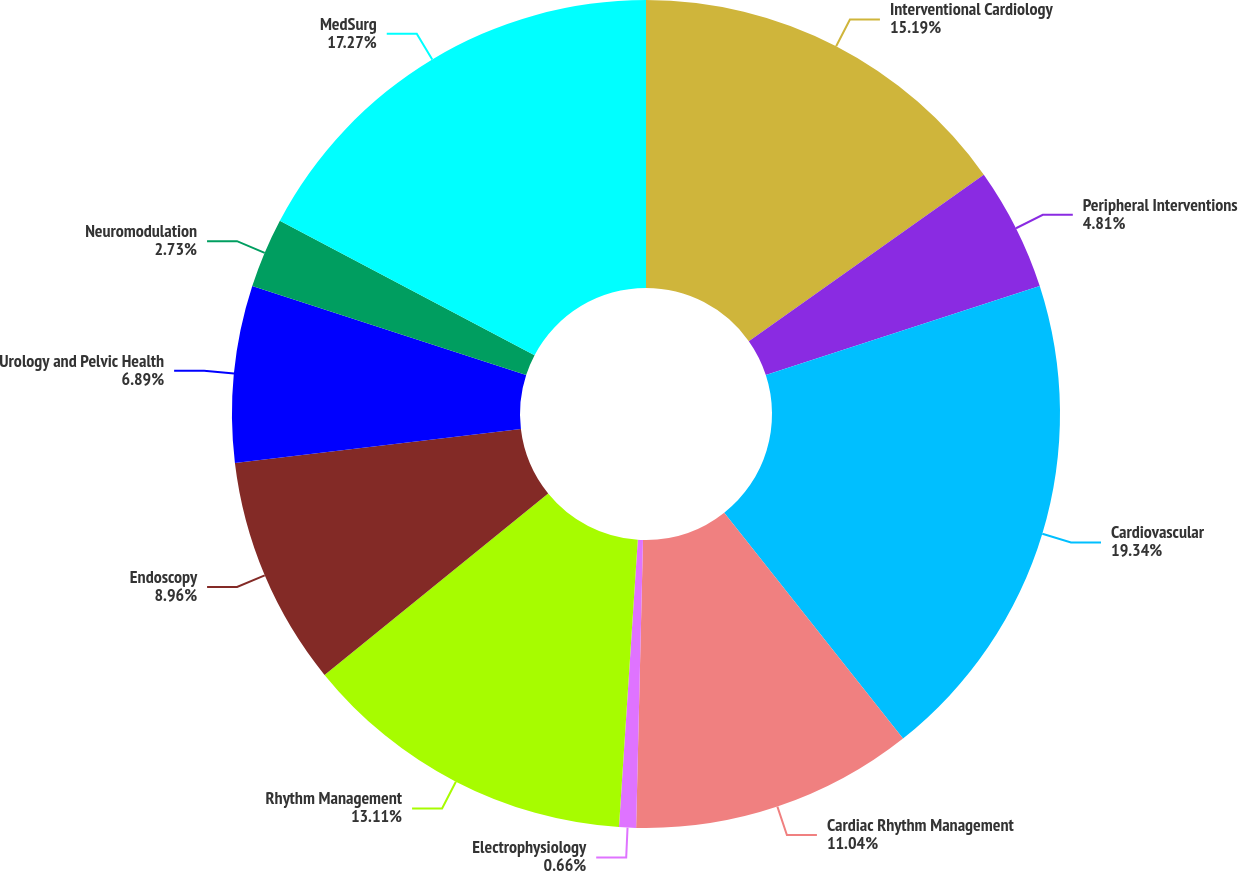<chart> <loc_0><loc_0><loc_500><loc_500><pie_chart><fcel>Interventional Cardiology<fcel>Peripheral Interventions<fcel>Cardiovascular<fcel>Cardiac Rhythm Management<fcel>Electrophysiology<fcel>Rhythm Management<fcel>Endoscopy<fcel>Urology and Pelvic Health<fcel>Neuromodulation<fcel>MedSurg<nl><fcel>15.19%<fcel>4.81%<fcel>19.34%<fcel>11.04%<fcel>0.66%<fcel>13.11%<fcel>8.96%<fcel>6.89%<fcel>2.73%<fcel>17.27%<nl></chart> 